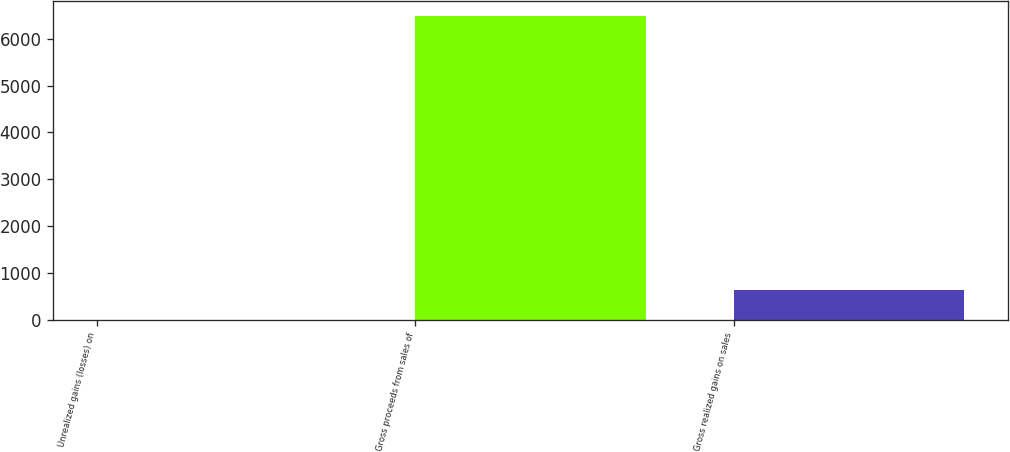Convert chart. <chart><loc_0><loc_0><loc_500><loc_500><bar_chart><fcel>Unrealized gains (losses) on<fcel>Gross proceeds from sales of<fcel>Gross realized gains on sales<nl><fcel>1<fcel>6489<fcel>649.8<nl></chart> 